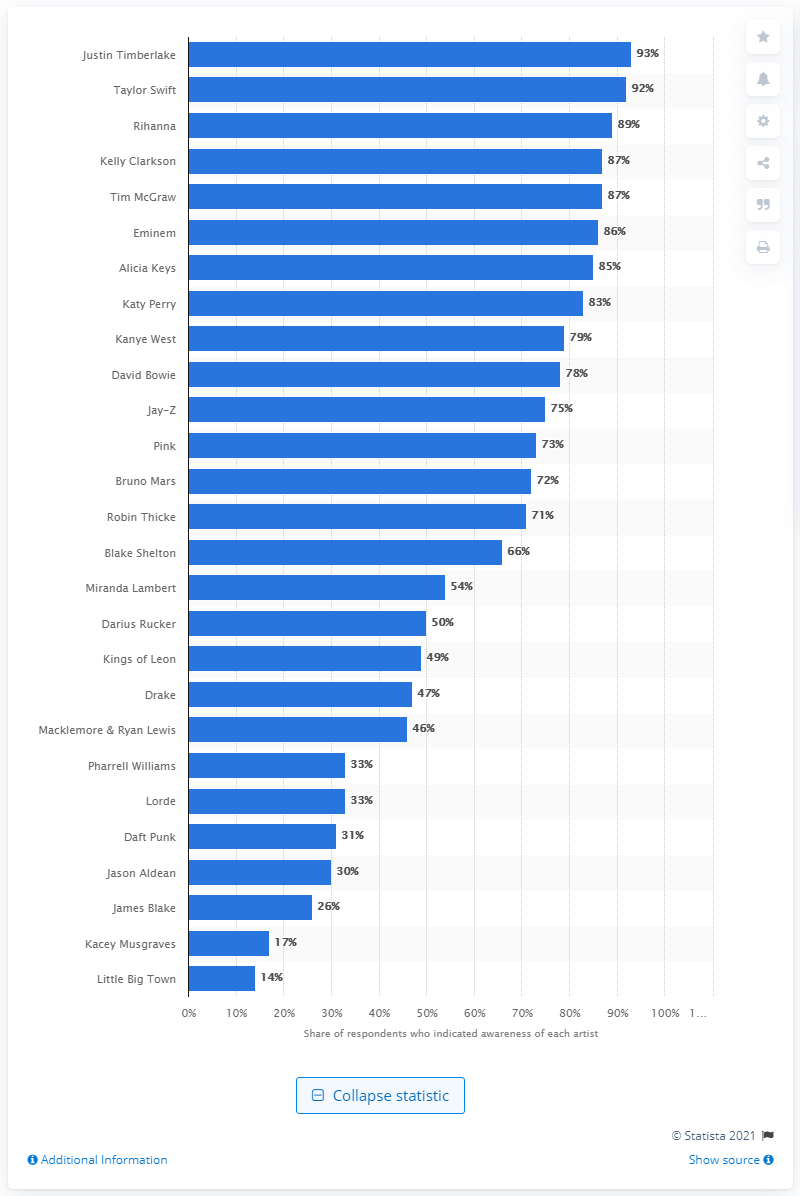Give some essential details in this illustration. David Bowie, a veteran musician, recently received an awareness rating of 78 percent. Lorde, a newcomer, received two Grammy Awards. 